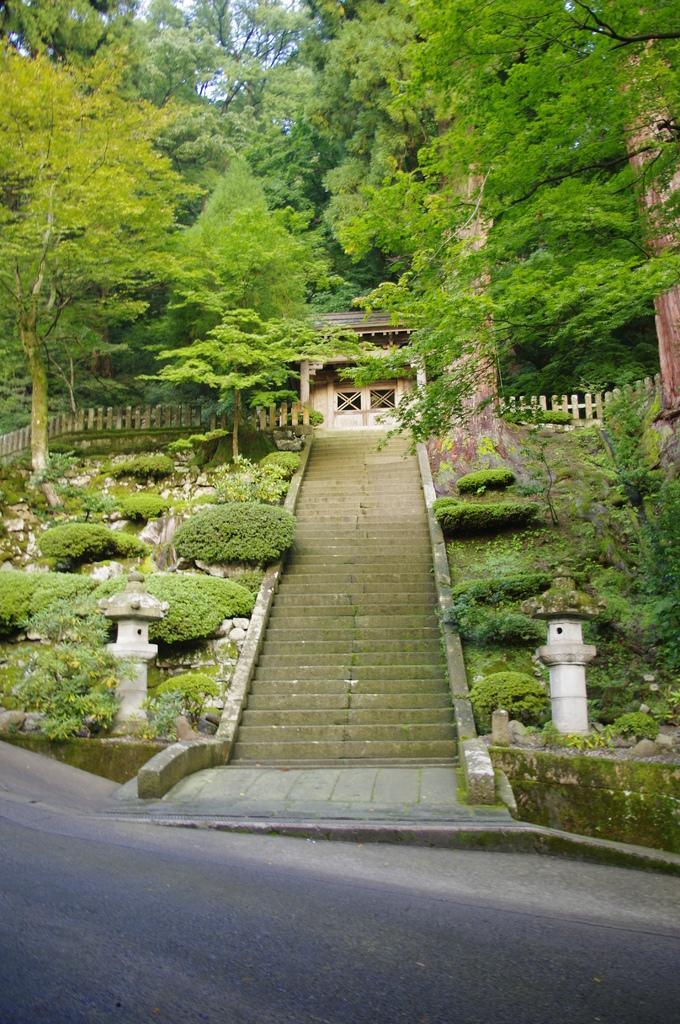Can you describe this image briefly? In this image there are poles and plants and there are steps. In the background there are trees and in the center there is a house and there is a fence. 